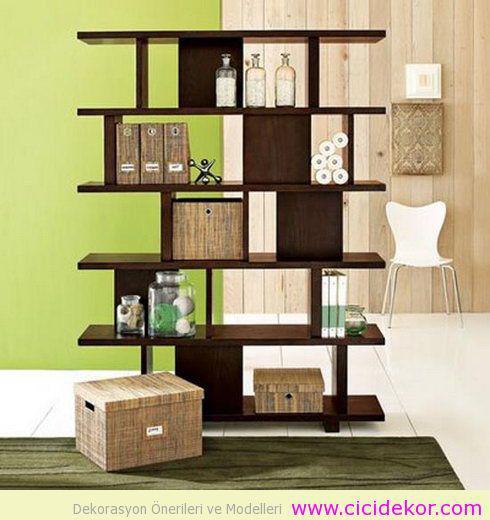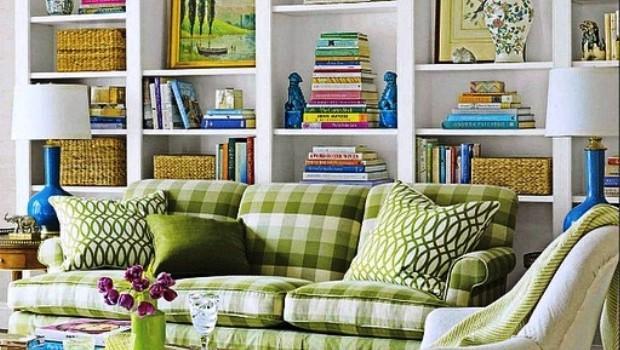The first image is the image on the left, the second image is the image on the right. Examine the images to the left and right. Is the description "In one image, white bookshelves run parallel on opposing walls." accurate? Answer yes or no. No. The first image is the image on the left, the second image is the image on the right. Considering the images on both sides, is "One image shows bookcases lining the left and right walls, with a floor between." valid? Answer yes or no. No. 